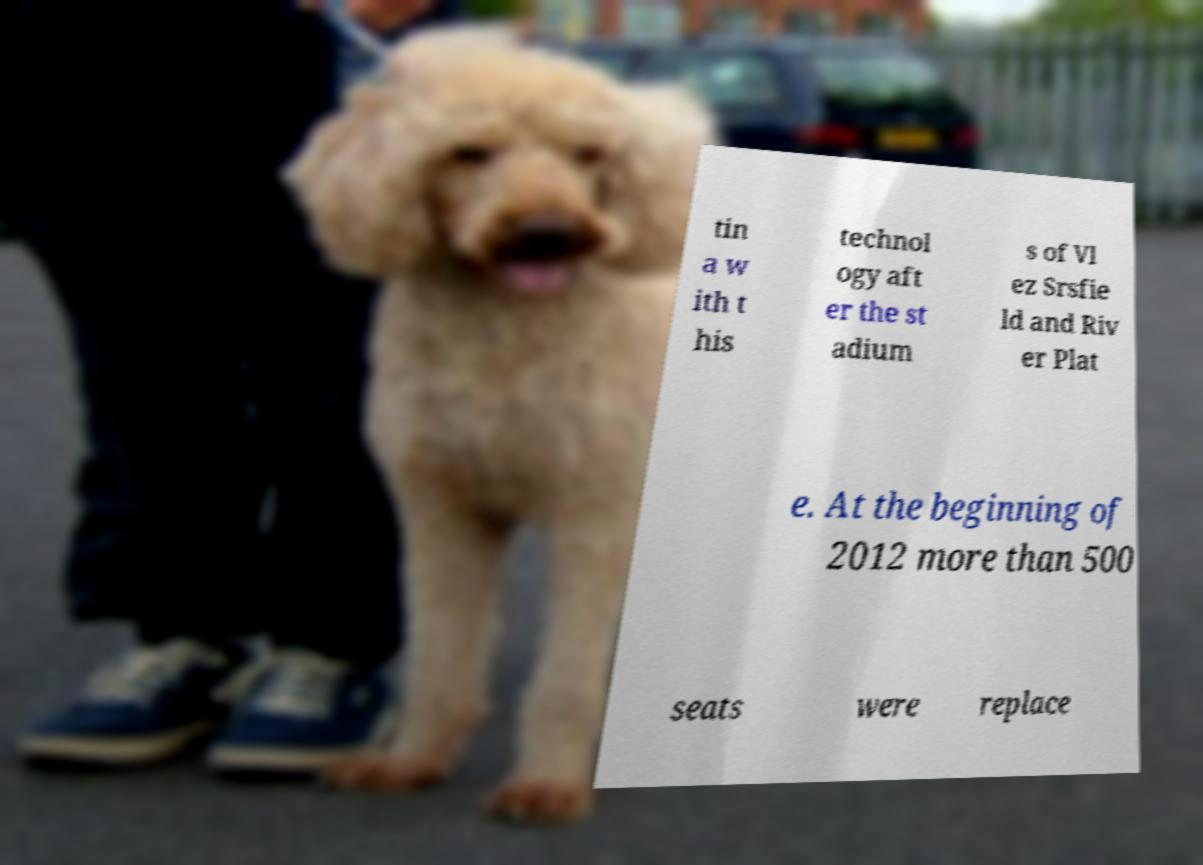I need the written content from this picture converted into text. Can you do that? tin a w ith t his technol ogy aft er the st adium s of Vl ez Srsfie ld and Riv er Plat e. At the beginning of 2012 more than 500 seats were replace 